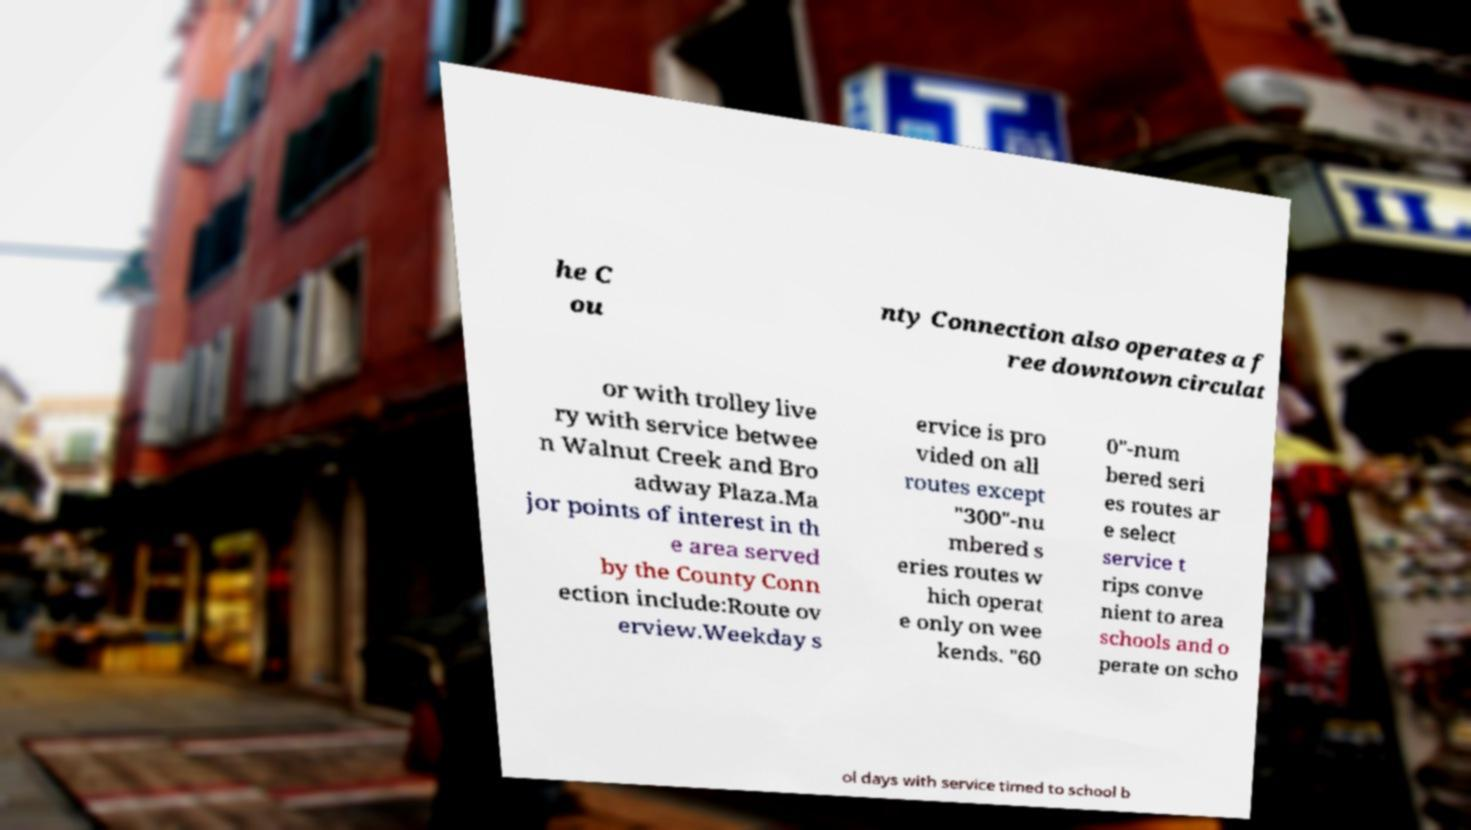Can you read and provide the text displayed in the image?This photo seems to have some interesting text. Can you extract and type it out for me? he C ou nty Connection also operates a f ree downtown circulat or with trolley live ry with service betwee n Walnut Creek and Bro adway Plaza.Ma jor points of interest in th e area served by the County Conn ection include:Route ov erview.Weekday s ervice is pro vided on all routes except "300"-nu mbered s eries routes w hich operat e only on wee kends. "60 0"-num bered seri es routes ar e select service t rips conve nient to area schools and o perate on scho ol days with service timed to school b 